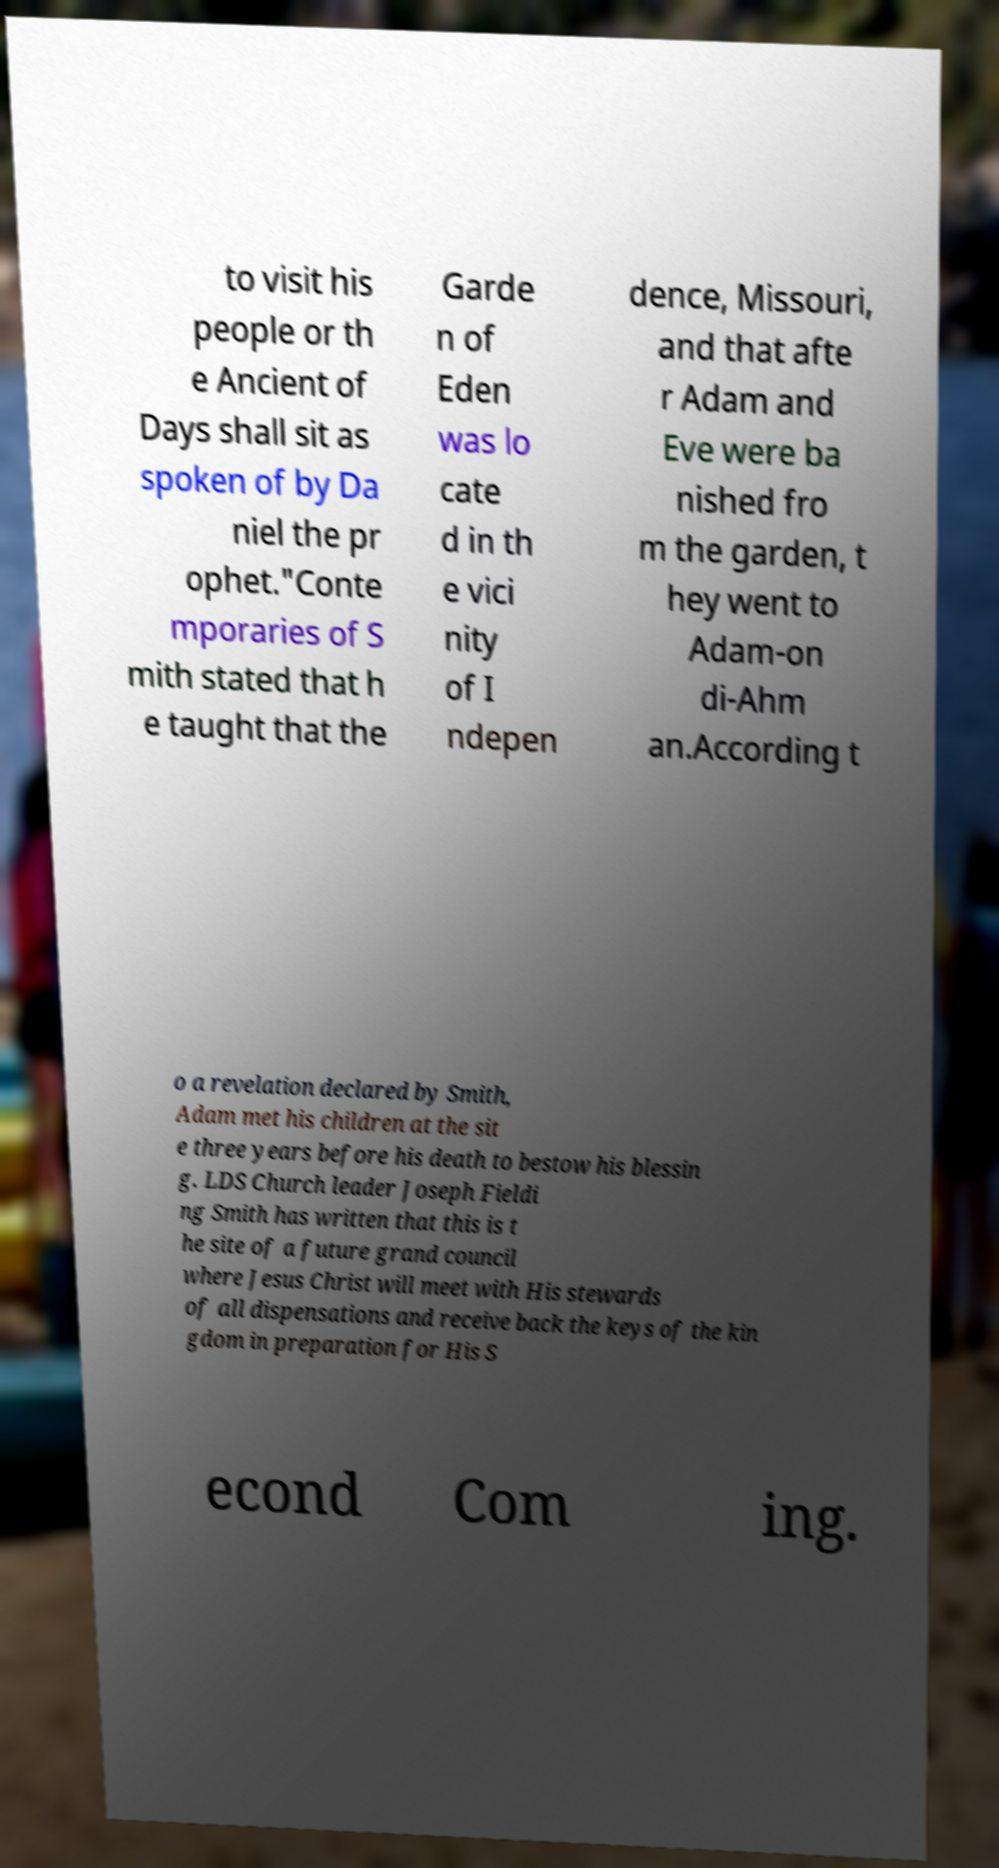Can you accurately transcribe the text from the provided image for me? to visit his people or th e Ancient of Days shall sit as spoken of by Da niel the pr ophet."Conte mporaries of S mith stated that h e taught that the Garde n of Eden was lo cate d in th e vici nity of I ndepen dence, Missouri, and that afte r Adam and Eve were ba nished fro m the garden, t hey went to Adam-on di-Ahm an.According t o a revelation declared by Smith, Adam met his children at the sit e three years before his death to bestow his blessin g. LDS Church leader Joseph Fieldi ng Smith has written that this is t he site of a future grand council where Jesus Christ will meet with His stewards of all dispensations and receive back the keys of the kin gdom in preparation for His S econd Com ing. 